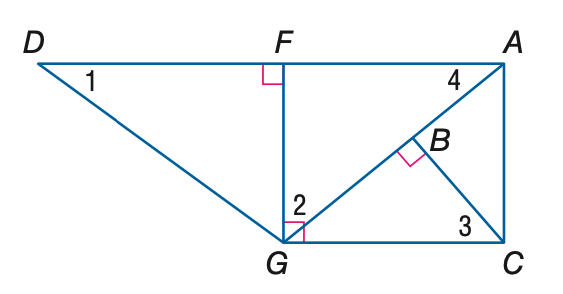Answer the mathemtical geometry problem and directly provide the correct option letter.
Question: Find the measure of \angle 3 if m \angle D G F = 53 and m \angle A G C = 40.
Choices: A: 37 B: 40 C: 50 D: 53 C 